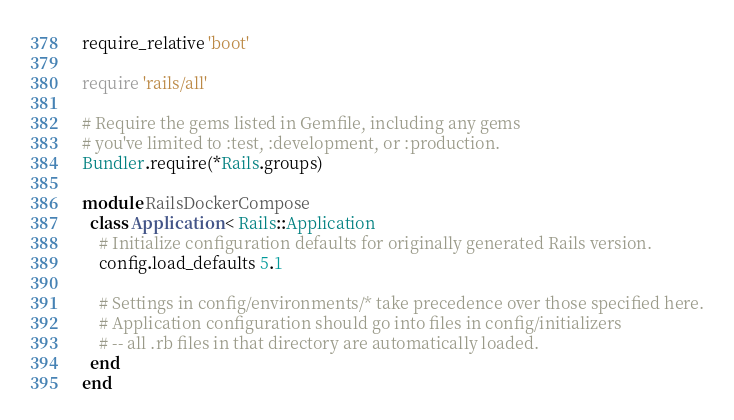Convert code to text. <code><loc_0><loc_0><loc_500><loc_500><_Ruby_>require_relative 'boot'

require 'rails/all'

# Require the gems listed in Gemfile, including any gems
# you've limited to :test, :development, or :production.
Bundler.require(*Rails.groups)

module RailsDockerCompose
  class Application < Rails::Application
    # Initialize configuration defaults for originally generated Rails version.
    config.load_defaults 5.1

    # Settings in config/environments/* take precedence over those specified here.
    # Application configuration should go into files in config/initializers
    # -- all .rb files in that directory are automatically loaded.
  end
end
</code> 